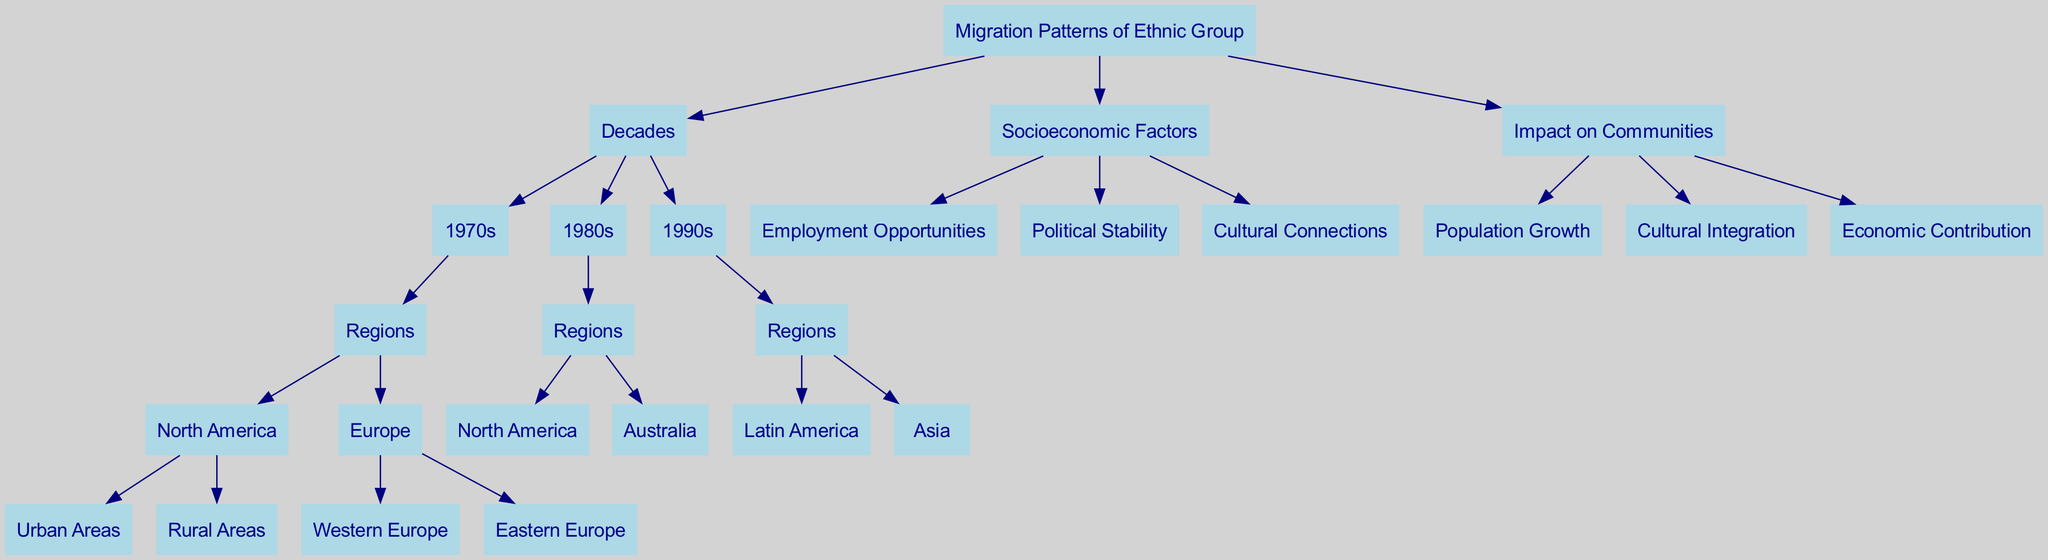What are the three decades represented in the tree? The diagram displays three decades as child nodes under "Decades." They are "1970s," "1980s," and "1990s."
Answer: 1970s, 1980s, 1990s How many regions are listed under the 1970s? Under the "1970s" node, there are two main regions listed, which are "North America" and "Europe."
Answer: 2 What is one reason for migration listed in the socioeconomic factors? In the "Socioeconomic Factors" section, one listed reason for migration is "Employment Opportunities."
Answer: Employment Opportunities What is the relationship between the "1990s" and "Latin America"? "Latin America" is a child node under "Regions," which in turn is a child node of "1990s." This indicates that migration to "Latin America" occurred during the "1990s."
Answer: Child node Which region is mentioned only in the 1980s? In the diagram, "Australia" is listed exclusively under the "1980s" node, indicating that it is a destination for migration only during that decade.
Answer: Australia What are the three impacts of migration on communities? The impacts of migration on communities, shown as children of the "Impact on Communities" node, include "Population Growth," "Cultural Integration," and "Economic Contribution."
Answer: Population Growth, Cultural Integration, Economic Contribution How many children does the "North America" region have? The "North America" region under the "1970s" node has two child nodes: "Urban Areas" and "Rural Areas," indicating that these are the subdivisions discussed for this region.
Answer: 2 What decade saw migration to both North America and Australia? The "1980s" is the decade that lists migration destinations to both "North America" and "Australia."
Answer: 1980s What is the total number of child nodes under "Socioeconomic Factors"? Under "Socioeconomic Factors," there are three child nodes: "Employment Opportunities," "Political Stability," and "Cultural Connections," totaling three factors that influence migration.
Answer: 3 